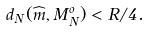<formula> <loc_0><loc_0><loc_500><loc_500>d _ { N } ( \widehat { m } , M _ { N } ^ { o } ) < R / 4 .</formula> 